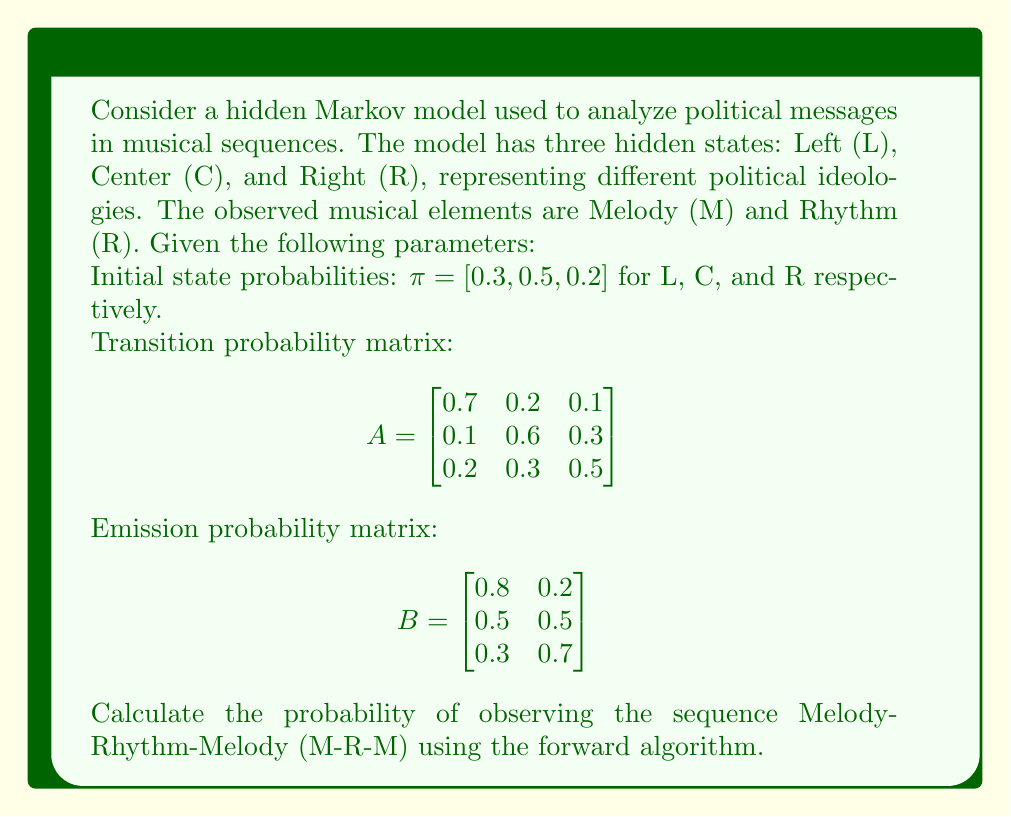Can you answer this question? To solve this problem using the forward algorithm, we need to calculate the forward probabilities for each step in the sequence. Let's denote the forward probability as $\alpha_t(i)$ for time $t$ and state $i$.

Step 1: Initialize the forward probabilities for t = 1 (M)
$\alpha_1(L) = \pi_L \cdot b_L(M) = 0.3 \cdot 0.8 = 0.24$
$\alpha_1(C) = \pi_C \cdot b_C(M) = 0.5 \cdot 0.5 = 0.25$
$\alpha_1(R) = \pi_R \cdot b_R(M) = 0.2 \cdot 0.3 = 0.06$

Step 2: Calculate forward probabilities for t = 2 (R)
$\alpha_2(L) = [0.24 \cdot 0.7 + 0.25 \cdot 0.1 + 0.06 \cdot 0.2] \cdot 0.2 = 0.0388$
$\alpha_2(C) = [0.24 \cdot 0.2 + 0.25 \cdot 0.6 + 0.06 \cdot 0.3] \cdot 0.5 = 0.0805$
$\alpha_2(R) = [0.24 \cdot 0.1 + 0.25 \cdot 0.3 + 0.06 \cdot 0.5] \cdot 0.7 = 0.0518$

Step 3: Calculate forward probabilities for t = 3 (M)
$\alpha_3(L) = [0.0388 \cdot 0.7 + 0.0805 \cdot 0.1 + 0.0518 \cdot 0.2] \cdot 0.8 = 0.0306$
$\alpha_3(C) = [0.0388 \cdot 0.2 + 0.0805 \cdot 0.6 + 0.0518 \cdot 0.3] \cdot 0.5 = 0.0316$
$\alpha_3(R) = [0.0388 \cdot 0.1 + 0.0805 \cdot 0.3 + 0.0518 \cdot 0.5] \cdot 0.3 = 0.0105$

Step 4: Sum the final forward probabilities
$P(M-R-M) = \alpha_3(L) + \alpha_3(C) + \alpha_3(R) = 0.0306 + 0.0316 + 0.0105 = 0.0727$

Therefore, the probability of observing the sequence M-R-M is approximately 0.0727 or 7.27%.
Answer: 0.0727 